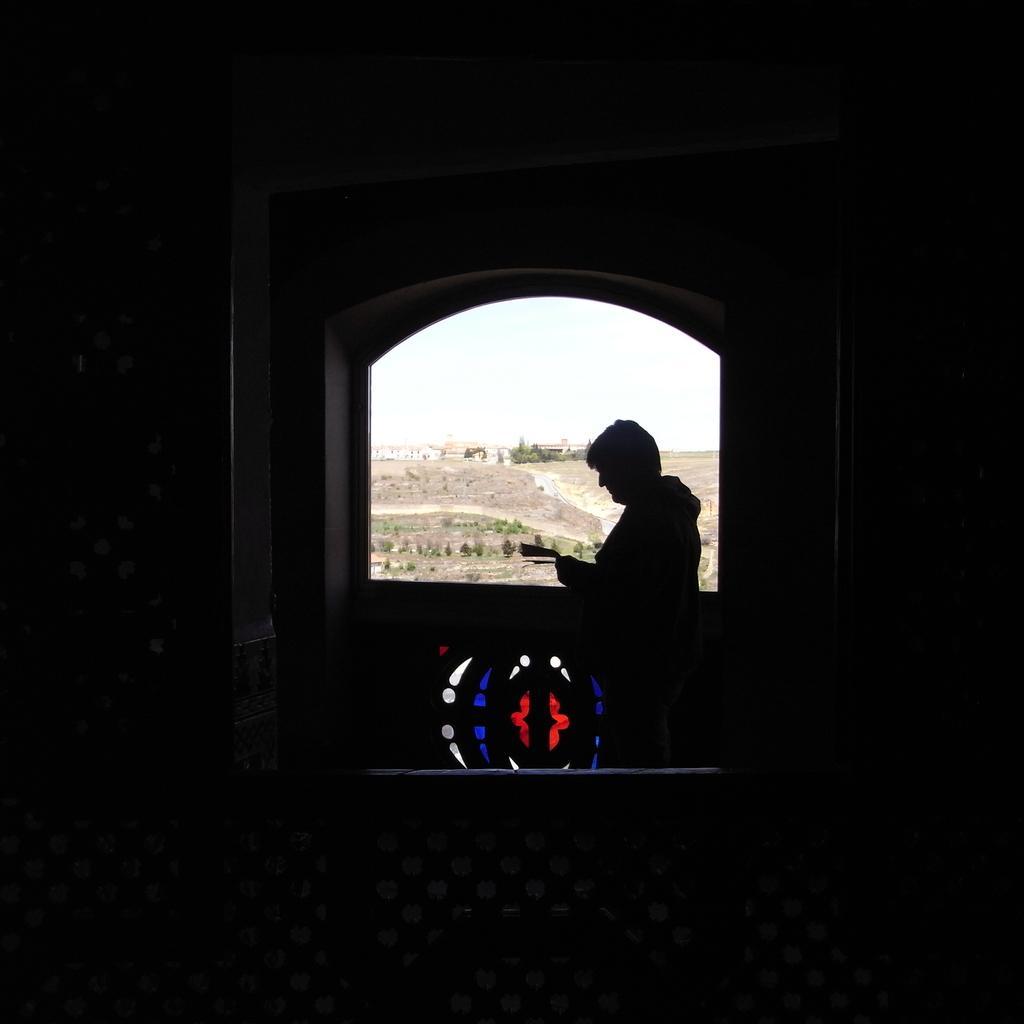Describe this image in one or two sentences. In the center of the picture we can see a person standing near a window, outside the window there are trees, land and building. In the foreground it is dark. 